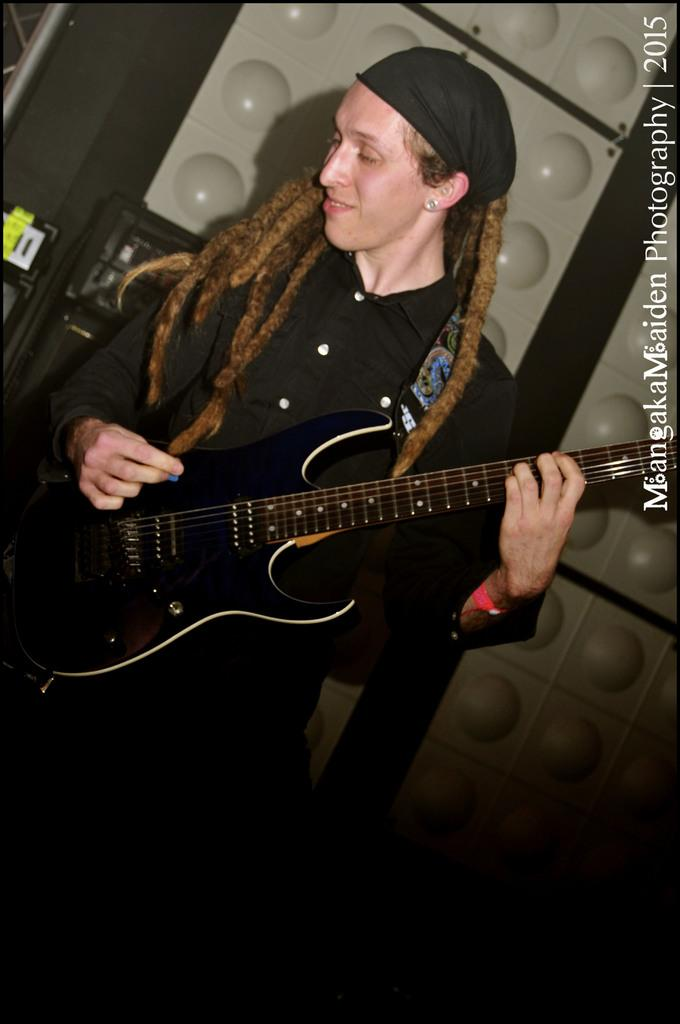Who is in the image? There is a person in the image. What is the person wearing? The person is wearing a black dress. What is the person holding? The person is holding a guitar. What can be seen in the background of the image? There are objects in the background of the image. What colors are the objects in the background? The objects in the background are black and grey in color. What type of bait is the person using to catch fish in the image? There is no indication of fishing or bait in the image; the person is holding a guitar. How does the earthquake affect the person and their surroundings in the image? There is no earthquake present in the image; it features a person holding a guitar. 